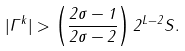<formula> <loc_0><loc_0><loc_500><loc_500>| \Gamma ^ { k } | > \left ( \frac { 2 \sigma - 1 } { 2 \sigma - 2 } \right ) 2 ^ { { L } - 2 } S .</formula> 